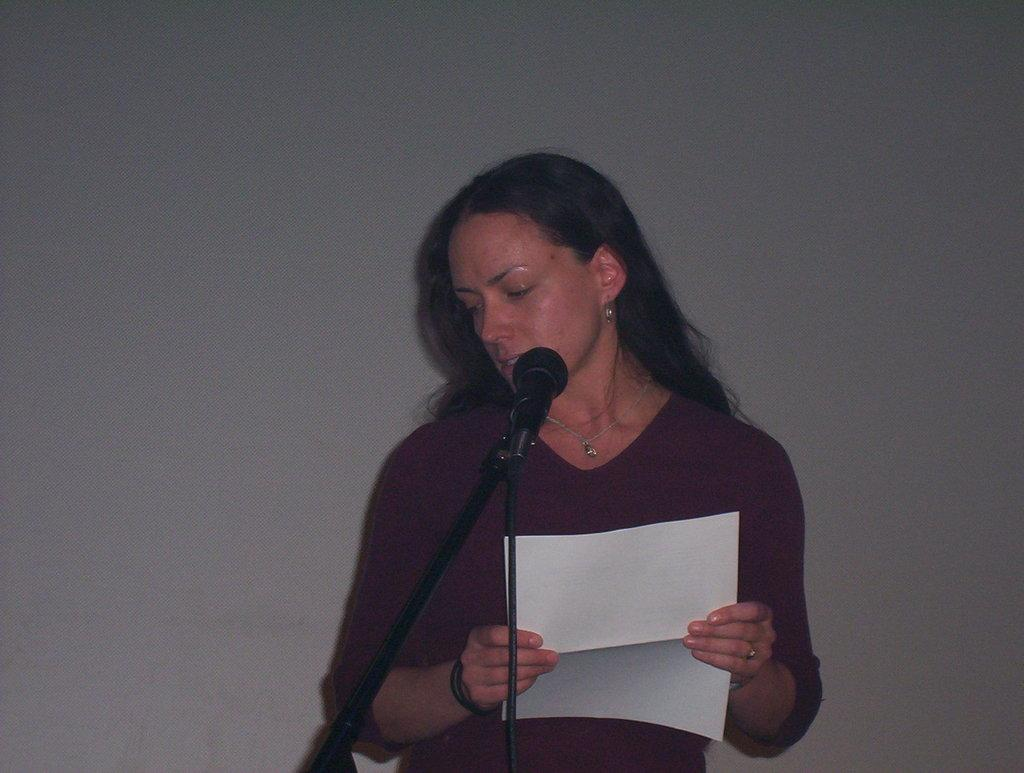Who is present in the image? There is a woman in the image. What is the woman doing in the image? The woman is standing in the image. What is the woman holding in her hands? The woman is holding a paper in her hands. What object can be seen on a stand in the image? There is a microphone on a stand in the image. What can be seen in the background of the image? There is a wall in the background of the image. What type of cloth is draped over the woman's hands in the image? There is no cloth draped over the woman's hands in the image; she is holding a paper. How does the woman's behavior change throughout the image? The image is a still photograph, so the woman's behavior does not change throughout the image. 